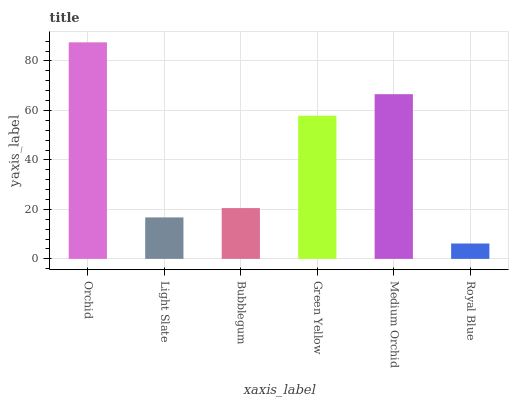Is Light Slate the minimum?
Answer yes or no. No. Is Light Slate the maximum?
Answer yes or no. No. Is Orchid greater than Light Slate?
Answer yes or no. Yes. Is Light Slate less than Orchid?
Answer yes or no. Yes. Is Light Slate greater than Orchid?
Answer yes or no. No. Is Orchid less than Light Slate?
Answer yes or no. No. Is Green Yellow the high median?
Answer yes or no. Yes. Is Bubblegum the low median?
Answer yes or no. Yes. Is Orchid the high median?
Answer yes or no. No. Is Royal Blue the low median?
Answer yes or no. No. 